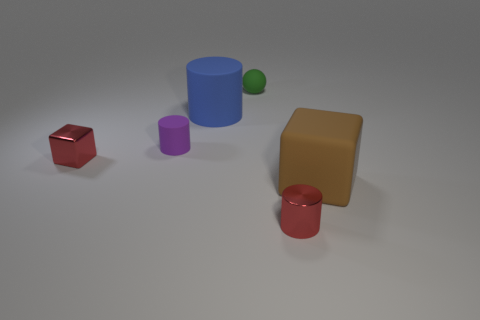Add 3 big spheres. How many objects exist? 9 Subtract all cubes. How many objects are left? 4 Subtract all tiny brown things. Subtract all small red things. How many objects are left? 4 Add 1 small metallic blocks. How many small metallic blocks are left? 2 Add 2 tiny green rubber objects. How many tiny green rubber objects exist? 3 Subtract 1 brown blocks. How many objects are left? 5 